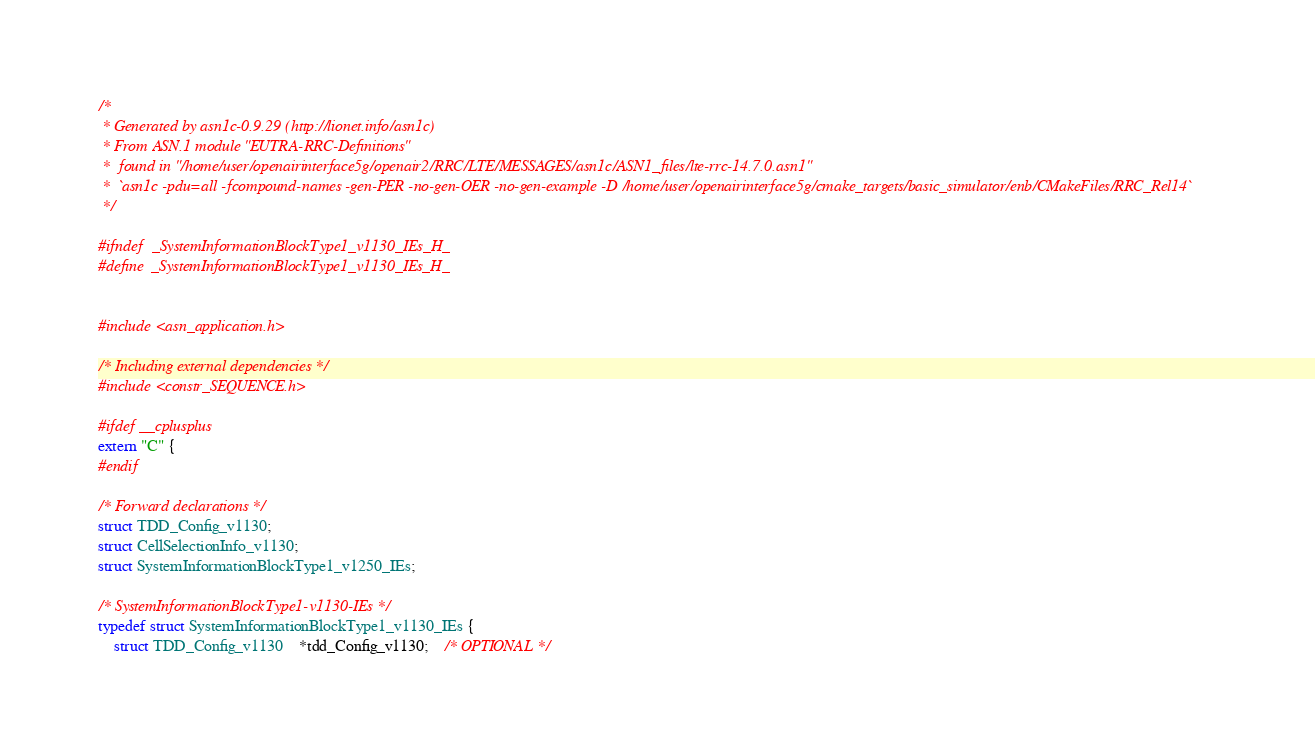<code> <loc_0><loc_0><loc_500><loc_500><_C_>/*
 * Generated by asn1c-0.9.29 (http://lionet.info/asn1c)
 * From ASN.1 module "EUTRA-RRC-Definitions"
 * 	found in "/home/user/openairinterface5g/openair2/RRC/LTE/MESSAGES/asn1c/ASN1_files/lte-rrc-14.7.0.asn1"
 * 	`asn1c -pdu=all -fcompound-names -gen-PER -no-gen-OER -no-gen-example -D /home/user/openairinterface5g/cmake_targets/basic_simulator/enb/CMakeFiles/RRC_Rel14`
 */

#ifndef	_SystemInformationBlockType1_v1130_IEs_H_
#define	_SystemInformationBlockType1_v1130_IEs_H_


#include <asn_application.h>

/* Including external dependencies */
#include <constr_SEQUENCE.h>

#ifdef __cplusplus
extern "C" {
#endif

/* Forward declarations */
struct TDD_Config_v1130;
struct CellSelectionInfo_v1130;
struct SystemInformationBlockType1_v1250_IEs;

/* SystemInformationBlockType1-v1130-IEs */
typedef struct SystemInformationBlockType1_v1130_IEs {
	struct TDD_Config_v1130	*tdd_Config_v1130;	/* OPTIONAL */</code> 